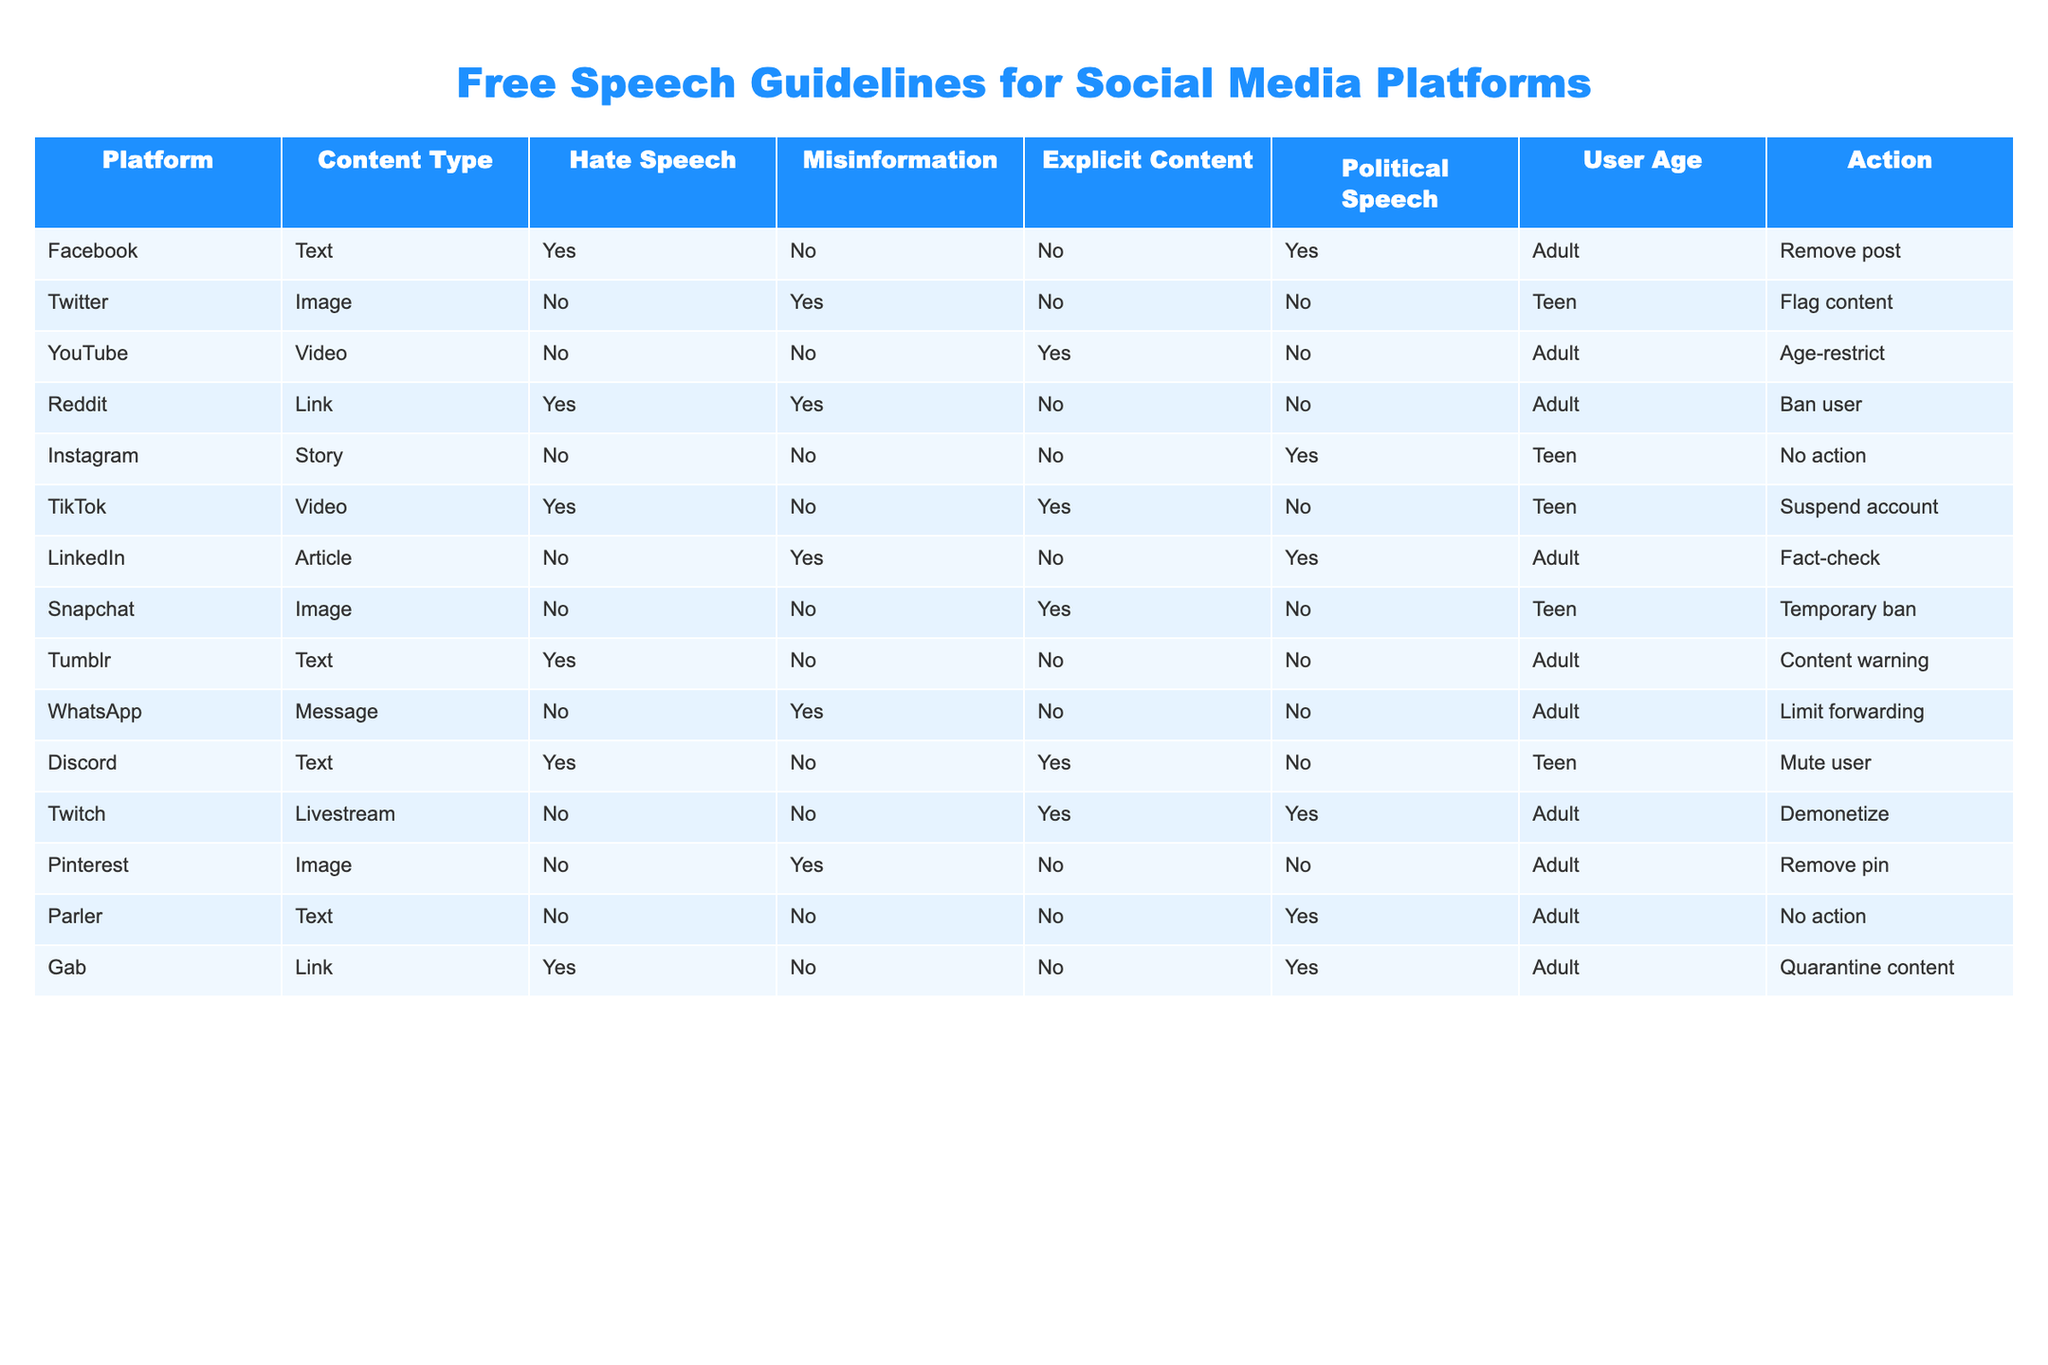What action does Twitter take for misinformation in images? According to the table, Twitter flags content when it is classified as misinformation in an image.
Answer: Flag content Which platforms take action against hate speech? The platforms that take action against hate speech are Facebook, Reddit, TikTok, Discord, and Gab.
Answer: Facebook, Reddit, TikTok, Discord, Gab How many platforms restrict explicit content as an action? The platforms taking action to restrict explicit content are YouTube (age-restrict), Snapchat (temporary ban), and TikTok (suspend account) — totaling 3 platforms.
Answer: 3 Is it true that Instagram takes any action against political speech? No, according to the table, Instagram does not take any action against political speech.
Answer: No What is the most common action taken by platforms for hate speech? By reviewing the actions taken by platforms for hate speech, the most common action is to remove posts; this is seen for Facebook and Tumblr.
Answer: Remove post How does the action for hate speech differ between adult and teen users? For adult users, hate speech can lead to post removal (Facebook) or user banning (Reddit), while for teen users, it can result in content muting (Discord) and account suspension (TikTok). This indicates a stricter approach for teen users due to their demographics.
Answer: Stricter for teens What percentage of platforms take no action against explicit content? Examining the data, there are 13 total platforms and 7 that take no action against explicit content (Twitter, Instagram, WhatsApp, Parler, Pinterest, Gab) leading to a percentage of (7/13) * 100 ≈ 53.85%.
Answer: Approximately 53.85% Which platform explicitly limits forwarding of misinformation, and what is the user demographic targeted? The platform WhatsApp limits forwarding of misinformation, and it targets adult users as indicated in the user age category.
Answer: WhatsApp, Adult Which content type is most likely to result in user banning, and what platform does this occur on? Hate speech linked to links results in user banning on Reddit, which targets adult users.
Answer: Links, Reddit 